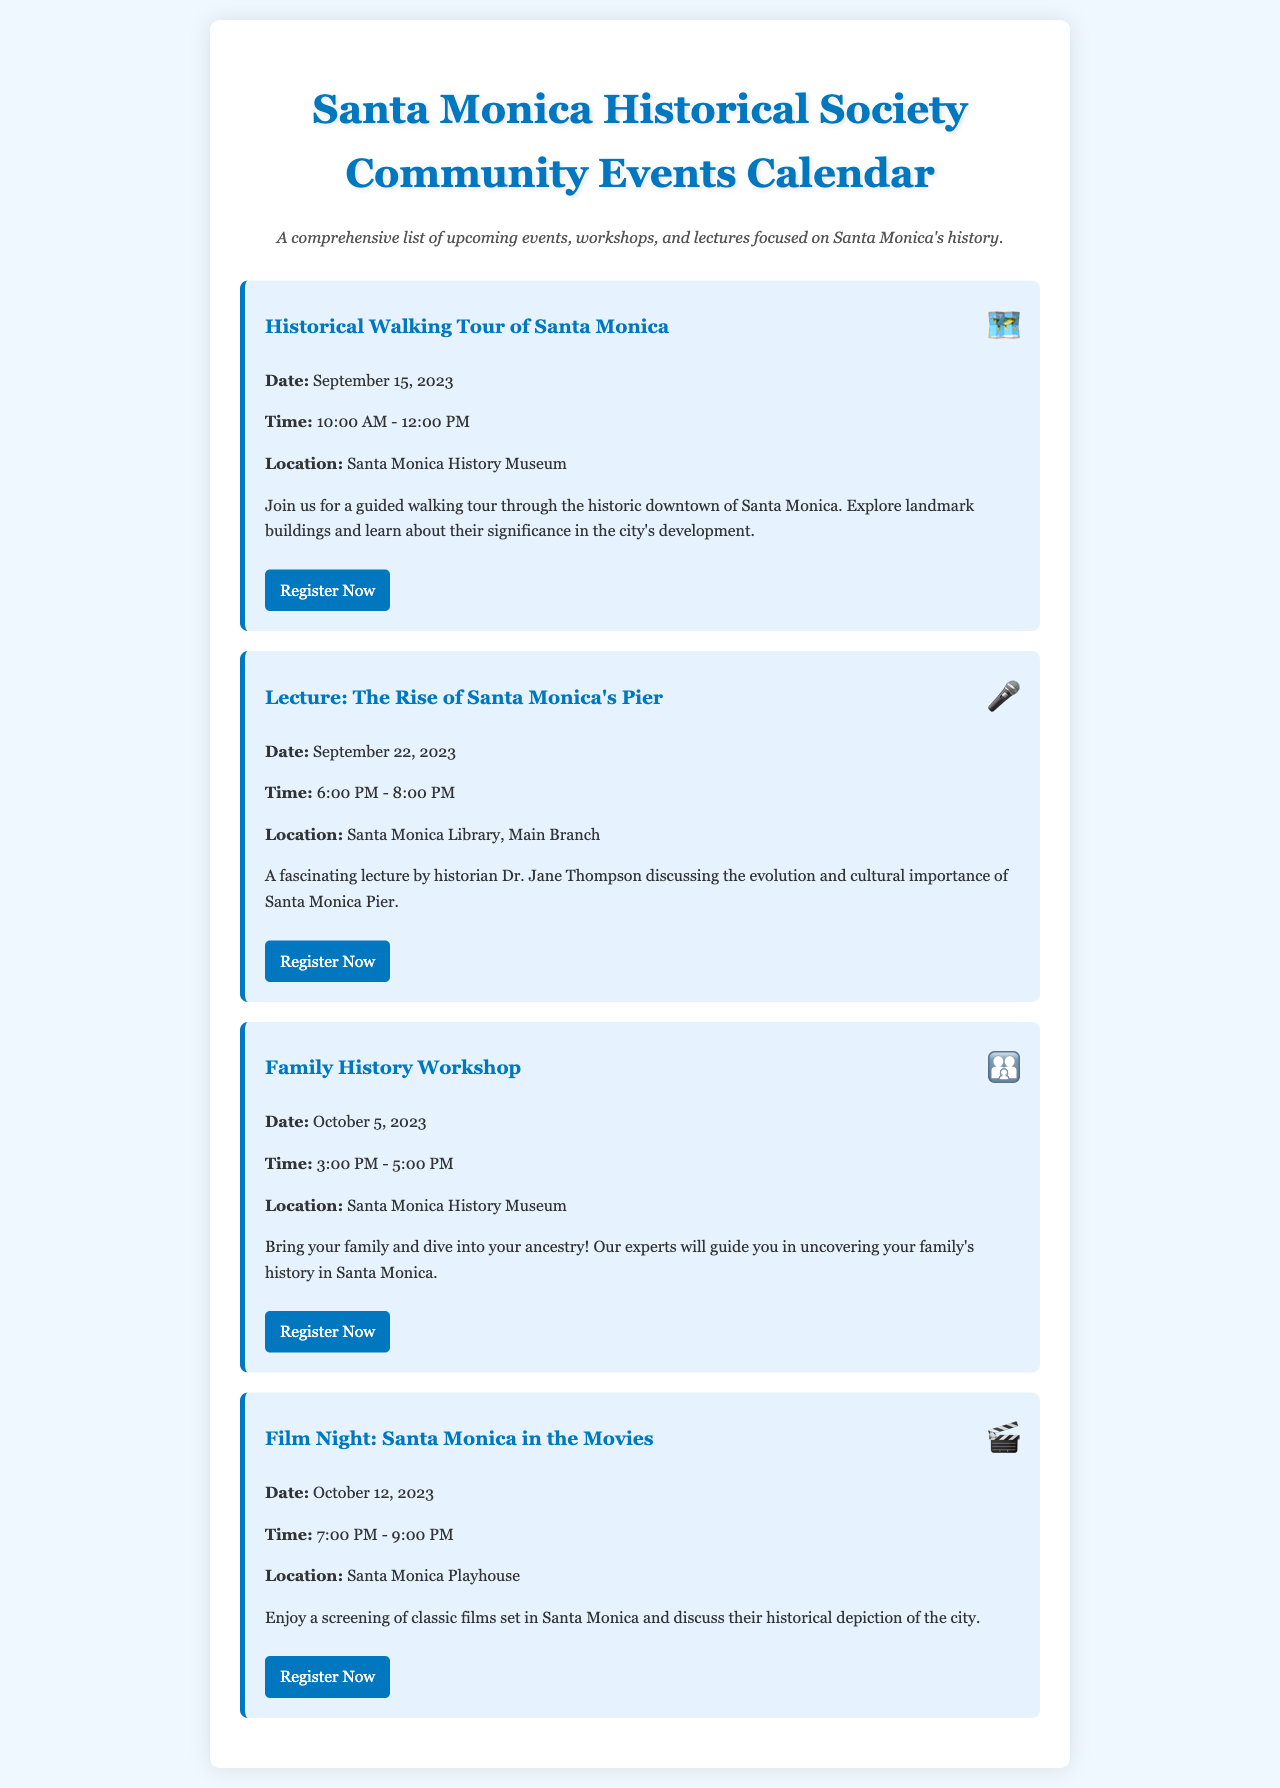What is the name of the first event listed? The first event listed is a guided tour, which is titled "Historical Walking Tour of Santa Monica."
Answer: Historical Walking Tour of Santa Monica What date is the "Lecture: The Rise of Santa Monica's Pier"? The date for this lecture is explicitly mentioned in the document.
Answer: September 22, 2023 What is the time for the "Family History Workshop"? The time for this workshop is clearly stated in the details.
Answer: 3:00 PM - 5:00 PM Where is the "Film Night: Santa Monica in the Movies" held? The location for this event is specified in the event details.
Answer: Santa Monica Playhouse How many events occur in September 2023? The document lists events for September and counts them for specific dates.
Answer: 2 events What type of icon represents the "Family History Workshop"? The icon is associated with this specific event type and is depicted next to its name.
Answer: 👨‍👩‍👦 What organization is hosting these events? The events are organized by a specific local organization, as indicated in the document title.
Answer: Santa Monica Historical Society What is a key theme of all events in the calendar? Each event has a focus that is consistent across the calendar as described in the introduction.
Answer: Santa Monica's history 